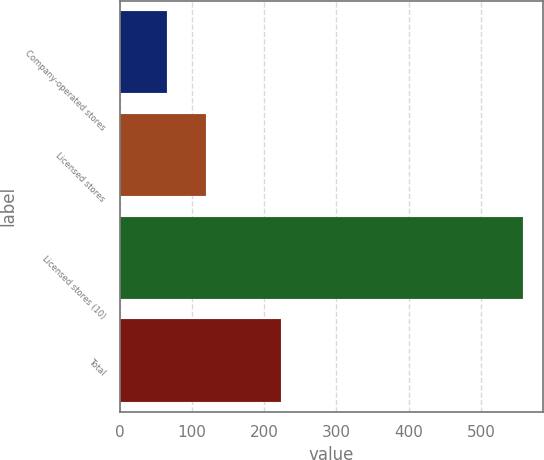<chart> <loc_0><loc_0><loc_500><loc_500><bar_chart><fcel>Company-operated stores<fcel>Licensed stores<fcel>Licensed stores (10)<fcel>Total<nl><fcel>64.8<fcel>119.6<fcel>558<fcel>223<nl></chart> 